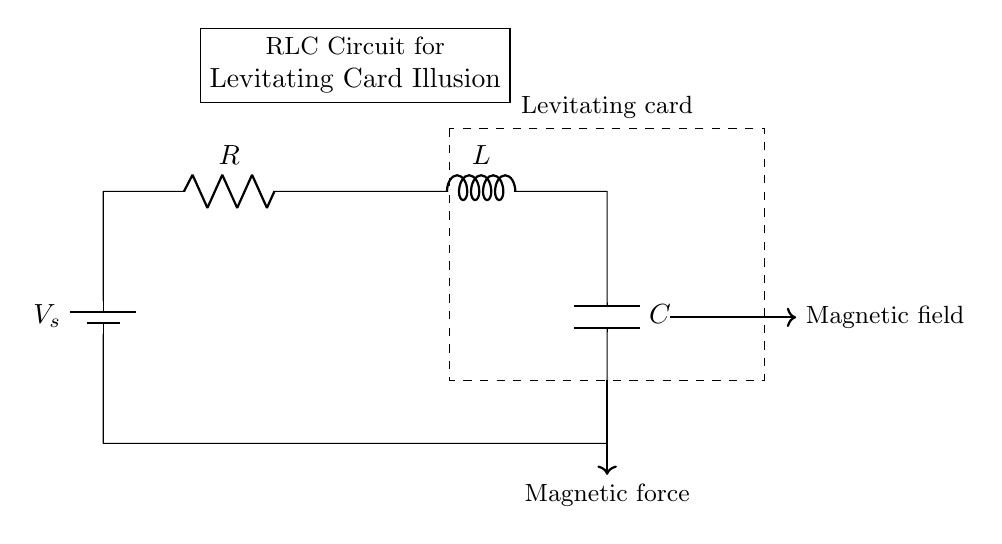What components are in the circuit? The circuit contains a resistor, an inductor, and a capacitor, which are the primary components of an RLC circuit. They are connected in series.
Answer: resistor, inductor, capacitor What is the purpose of the battery in this circuit? The battery supplies voltage to the circuit, enabling the RLC circuit to generate an oscillating current, which is necessary for creating the magnetic field for levitation.
Answer: voltage source What magnetic effect does the inductor create in this circuit? The inductor generates a magnetic field as current flows through it, which interacts with the levitating card, providing the lift necessary for the illusion.
Answer: magnetic field How many loops are in the circuit? There is one complete loop, as the components are connected in series, forming a single pathway for current.
Answer: one loop What happens to the resonance frequency if the capacitance increases? If the capacitance increases, the resonance frequency decreases, as resonance frequency is inversely related to both inductance and capacitance.
Answer: decreases Why is the capacitor necessary in this circuit? The capacitor stores electrical energy and releases it at a specific rate, allowing for oscillations in the circuit which create a time-varying magnetic field for levitation.
Answer: energy storage What relationship do R, L, and C have in this circuit? R, L, and C together determine the damping and oscillation characteristics of the circuit, influencing how effectively the magnetic field can stabilize the levitating card.
Answer: damping and oscillation characteristics 